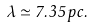<formula> <loc_0><loc_0><loc_500><loc_500>\lambda \simeq 7 . 3 5 \, p c .</formula> 